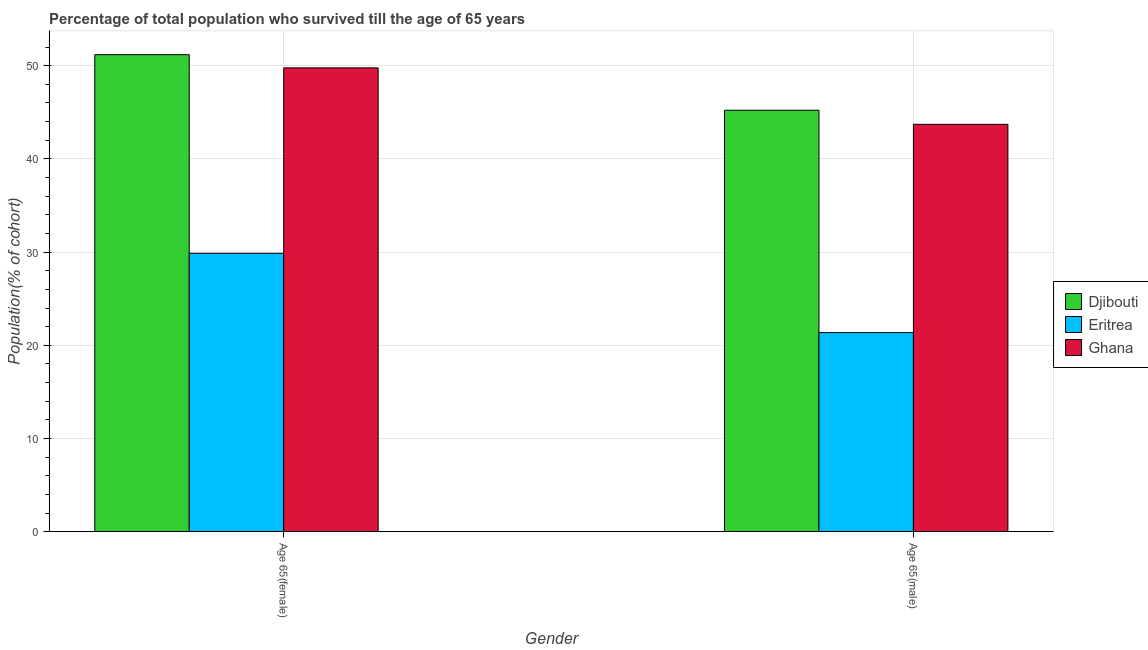How many different coloured bars are there?
Make the answer very short. 3. How many groups of bars are there?
Ensure brevity in your answer.  2. What is the label of the 2nd group of bars from the left?
Give a very brief answer. Age 65(male). What is the percentage of male population who survived till age of 65 in Djibouti?
Make the answer very short. 45.22. Across all countries, what is the maximum percentage of male population who survived till age of 65?
Keep it short and to the point. 45.22. Across all countries, what is the minimum percentage of female population who survived till age of 65?
Give a very brief answer. 29.87. In which country was the percentage of female population who survived till age of 65 maximum?
Make the answer very short. Djibouti. In which country was the percentage of male population who survived till age of 65 minimum?
Offer a terse response. Eritrea. What is the total percentage of male population who survived till age of 65 in the graph?
Provide a succinct answer. 110.29. What is the difference between the percentage of male population who survived till age of 65 in Djibouti and that in Ghana?
Your answer should be very brief. 1.51. What is the difference between the percentage of female population who survived till age of 65 in Ghana and the percentage of male population who survived till age of 65 in Djibouti?
Your answer should be very brief. 4.54. What is the average percentage of female population who survived till age of 65 per country?
Give a very brief answer. 43.61. What is the difference between the percentage of male population who survived till age of 65 and percentage of female population who survived till age of 65 in Eritrea?
Keep it short and to the point. -8.51. What is the ratio of the percentage of female population who survived till age of 65 in Eritrea to that in Ghana?
Provide a succinct answer. 0.6. Is the percentage of female population who survived till age of 65 in Djibouti less than that in Eritrea?
Your answer should be compact. No. In how many countries, is the percentage of male population who survived till age of 65 greater than the average percentage of male population who survived till age of 65 taken over all countries?
Your response must be concise. 2. What does the 2nd bar from the left in Age 65(female) represents?
Make the answer very short. Eritrea. What does the 2nd bar from the right in Age 65(male) represents?
Your answer should be very brief. Eritrea. How many bars are there?
Provide a succinct answer. 6. Are the values on the major ticks of Y-axis written in scientific E-notation?
Your answer should be compact. No. Does the graph contain any zero values?
Your answer should be very brief. No. Does the graph contain grids?
Give a very brief answer. Yes. How are the legend labels stacked?
Offer a very short reply. Vertical. What is the title of the graph?
Offer a terse response. Percentage of total population who survived till the age of 65 years. What is the label or title of the Y-axis?
Ensure brevity in your answer.  Population(% of cohort). What is the Population(% of cohort) of Djibouti in Age 65(female)?
Provide a short and direct response. 51.18. What is the Population(% of cohort) in Eritrea in Age 65(female)?
Give a very brief answer. 29.87. What is the Population(% of cohort) of Ghana in Age 65(female)?
Provide a succinct answer. 49.77. What is the Population(% of cohort) of Djibouti in Age 65(male)?
Ensure brevity in your answer.  45.22. What is the Population(% of cohort) of Eritrea in Age 65(male)?
Your answer should be compact. 21.36. What is the Population(% of cohort) of Ghana in Age 65(male)?
Give a very brief answer. 43.71. Across all Gender, what is the maximum Population(% of cohort) of Djibouti?
Offer a very short reply. 51.18. Across all Gender, what is the maximum Population(% of cohort) in Eritrea?
Offer a terse response. 29.87. Across all Gender, what is the maximum Population(% of cohort) of Ghana?
Ensure brevity in your answer.  49.77. Across all Gender, what is the minimum Population(% of cohort) of Djibouti?
Make the answer very short. 45.22. Across all Gender, what is the minimum Population(% of cohort) in Eritrea?
Your answer should be very brief. 21.36. Across all Gender, what is the minimum Population(% of cohort) in Ghana?
Your response must be concise. 43.71. What is the total Population(% of cohort) of Djibouti in the graph?
Your answer should be compact. 96.4. What is the total Population(% of cohort) in Eritrea in the graph?
Offer a very short reply. 51.23. What is the total Population(% of cohort) of Ghana in the graph?
Keep it short and to the point. 93.48. What is the difference between the Population(% of cohort) in Djibouti in Age 65(female) and that in Age 65(male)?
Make the answer very short. 5.96. What is the difference between the Population(% of cohort) of Eritrea in Age 65(female) and that in Age 65(male)?
Ensure brevity in your answer.  8.51. What is the difference between the Population(% of cohort) of Ghana in Age 65(female) and that in Age 65(male)?
Provide a succinct answer. 6.06. What is the difference between the Population(% of cohort) in Djibouti in Age 65(female) and the Population(% of cohort) in Eritrea in Age 65(male)?
Your answer should be compact. 29.82. What is the difference between the Population(% of cohort) of Djibouti in Age 65(female) and the Population(% of cohort) of Ghana in Age 65(male)?
Provide a short and direct response. 7.47. What is the difference between the Population(% of cohort) of Eritrea in Age 65(female) and the Population(% of cohort) of Ghana in Age 65(male)?
Ensure brevity in your answer.  -13.84. What is the average Population(% of cohort) of Djibouti per Gender?
Give a very brief answer. 48.2. What is the average Population(% of cohort) of Eritrea per Gender?
Your response must be concise. 25.61. What is the average Population(% of cohort) of Ghana per Gender?
Provide a succinct answer. 46.74. What is the difference between the Population(% of cohort) in Djibouti and Population(% of cohort) in Eritrea in Age 65(female)?
Provide a short and direct response. 21.31. What is the difference between the Population(% of cohort) of Djibouti and Population(% of cohort) of Ghana in Age 65(female)?
Offer a terse response. 1.42. What is the difference between the Population(% of cohort) in Eritrea and Population(% of cohort) in Ghana in Age 65(female)?
Give a very brief answer. -19.9. What is the difference between the Population(% of cohort) of Djibouti and Population(% of cohort) of Eritrea in Age 65(male)?
Offer a terse response. 23.86. What is the difference between the Population(% of cohort) of Djibouti and Population(% of cohort) of Ghana in Age 65(male)?
Your answer should be very brief. 1.51. What is the difference between the Population(% of cohort) of Eritrea and Population(% of cohort) of Ghana in Age 65(male)?
Offer a terse response. -22.35. What is the ratio of the Population(% of cohort) of Djibouti in Age 65(female) to that in Age 65(male)?
Offer a very short reply. 1.13. What is the ratio of the Population(% of cohort) of Eritrea in Age 65(female) to that in Age 65(male)?
Offer a terse response. 1.4. What is the ratio of the Population(% of cohort) in Ghana in Age 65(female) to that in Age 65(male)?
Your answer should be compact. 1.14. What is the difference between the highest and the second highest Population(% of cohort) of Djibouti?
Offer a very short reply. 5.96. What is the difference between the highest and the second highest Population(% of cohort) in Eritrea?
Keep it short and to the point. 8.51. What is the difference between the highest and the second highest Population(% of cohort) in Ghana?
Keep it short and to the point. 6.06. What is the difference between the highest and the lowest Population(% of cohort) of Djibouti?
Your response must be concise. 5.96. What is the difference between the highest and the lowest Population(% of cohort) of Eritrea?
Your answer should be compact. 8.51. What is the difference between the highest and the lowest Population(% of cohort) of Ghana?
Make the answer very short. 6.06. 